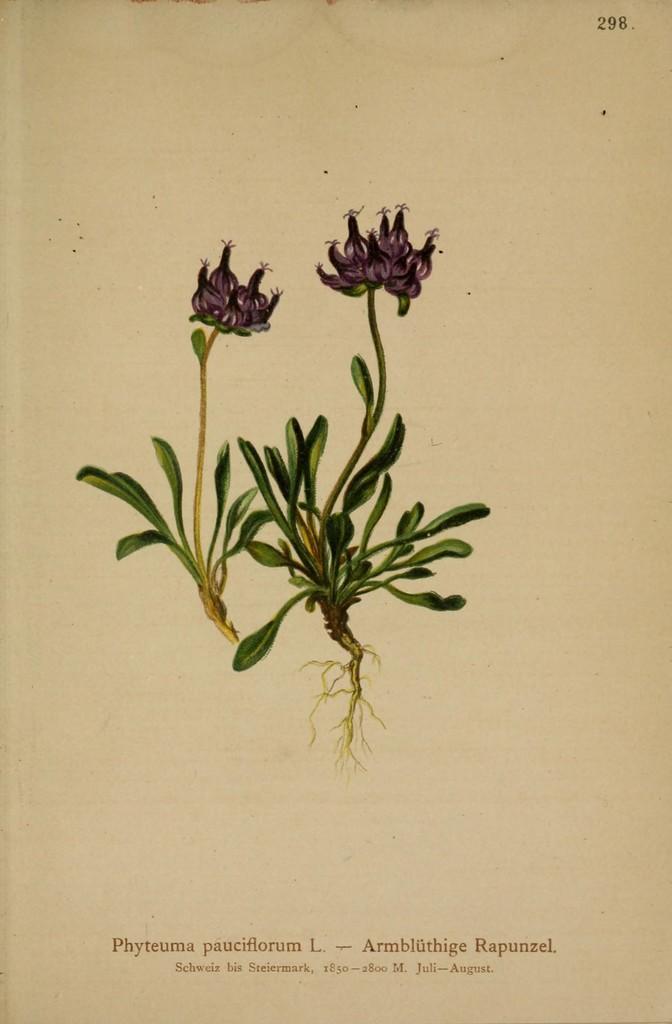Describe this image in one or two sentences. In this image I can see the paper. On the paper I can see the two plants with flowers. I can see these flowers are in purple color. I can see something is written at the bottom of the paper. 